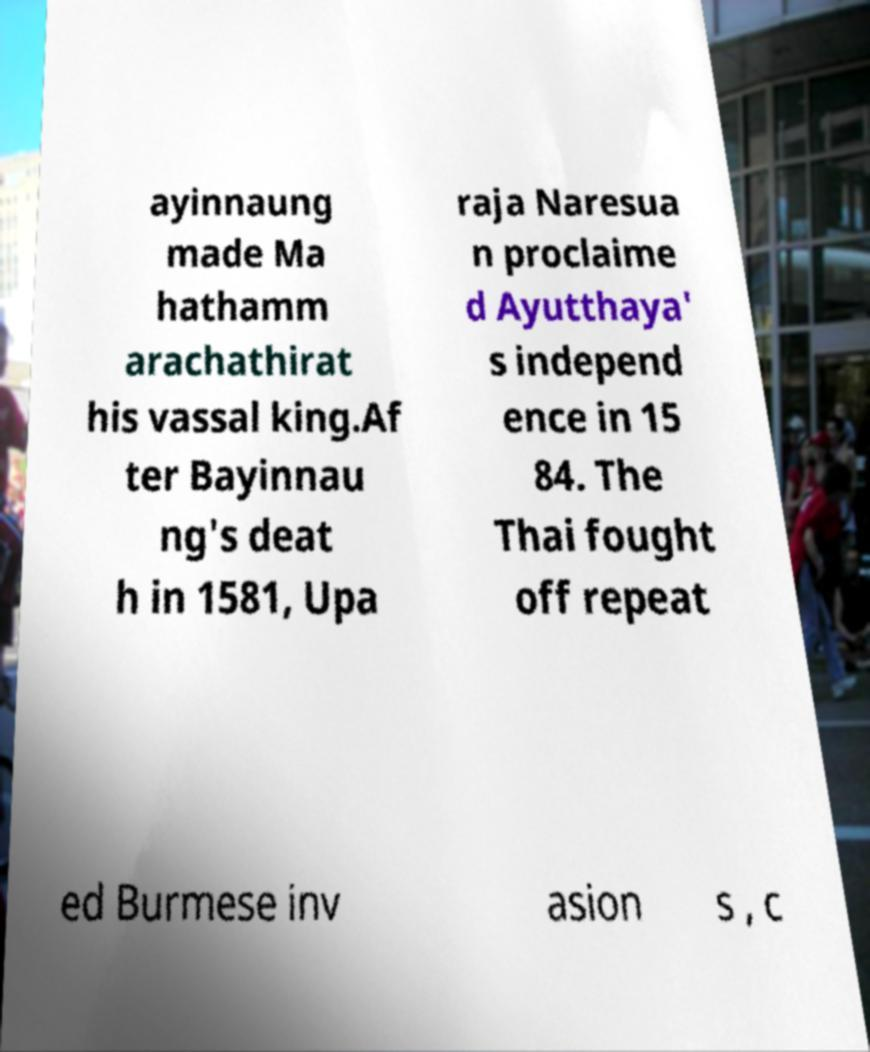For documentation purposes, I need the text within this image transcribed. Could you provide that? ayinnaung made Ma hathamm arachathirat his vassal king.Af ter Bayinnau ng's deat h in 1581, Upa raja Naresua n proclaime d Ayutthaya' s independ ence in 15 84. The Thai fought off repeat ed Burmese inv asion s , c 